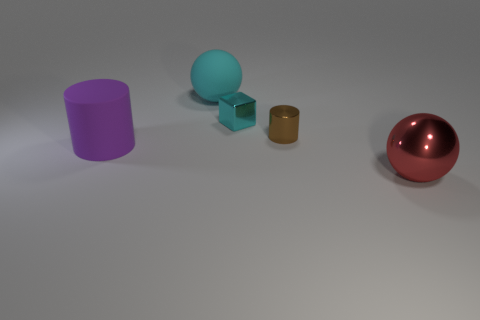Are there more tiny cyan rubber things than tiny cyan shiny blocks?
Your answer should be very brief. No. There is a large matte thing behind the shiny cylinder; does it have the same shape as the red object?
Offer a terse response. Yes. How many balls are both in front of the small brown metal thing and behind the brown metallic cylinder?
Your answer should be compact. 0. How many tiny brown objects are the same shape as the big purple thing?
Make the answer very short. 1. What is the color of the big object that is to the right of the object that is behind the tiny cyan thing?
Keep it short and to the point. Red. Do the cyan metallic thing and the rubber thing that is in front of the brown metal cylinder have the same shape?
Offer a terse response. No. There is a big ball left of the ball in front of the large sphere to the left of the big red thing; what is its material?
Your answer should be compact. Rubber. Are there any purple cylinders of the same size as the cyan metal thing?
Offer a very short reply. No. What is the size of the red ball that is made of the same material as the cyan block?
Your response must be concise. Large. What shape is the brown thing?
Your answer should be compact. Cylinder. 